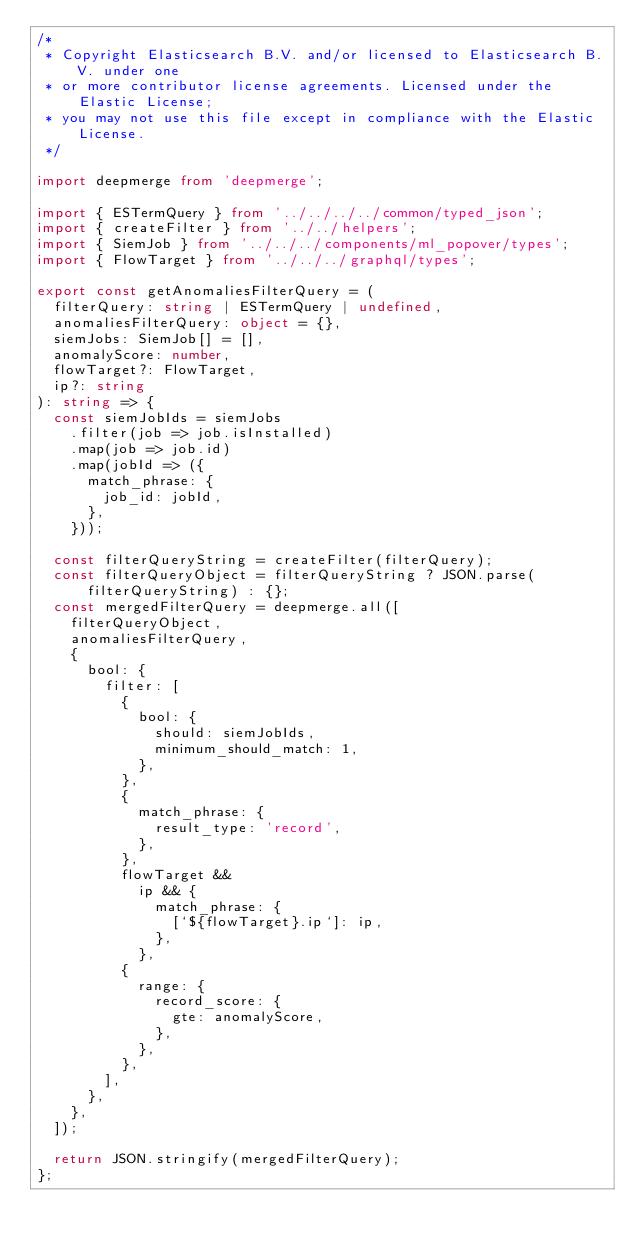Convert code to text. <code><loc_0><loc_0><loc_500><loc_500><_TypeScript_>/*
 * Copyright Elasticsearch B.V. and/or licensed to Elasticsearch B.V. under one
 * or more contributor license agreements. Licensed under the Elastic License;
 * you may not use this file except in compliance with the Elastic License.
 */

import deepmerge from 'deepmerge';

import { ESTermQuery } from '../../../../common/typed_json';
import { createFilter } from '../../helpers';
import { SiemJob } from '../../../components/ml_popover/types';
import { FlowTarget } from '../../../graphql/types';

export const getAnomaliesFilterQuery = (
  filterQuery: string | ESTermQuery | undefined,
  anomaliesFilterQuery: object = {},
  siemJobs: SiemJob[] = [],
  anomalyScore: number,
  flowTarget?: FlowTarget,
  ip?: string
): string => {
  const siemJobIds = siemJobs
    .filter(job => job.isInstalled)
    .map(job => job.id)
    .map(jobId => ({
      match_phrase: {
        job_id: jobId,
      },
    }));

  const filterQueryString = createFilter(filterQuery);
  const filterQueryObject = filterQueryString ? JSON.parse(filterQueryString) : {};
  const mergedFilterQuery = deepmerge.all([
    filterQueryObject,
    anomaliesFilterQuery,
    {
      bool: {
        filter: [
          {
            bool: {
              should: siemJobIds,
              minimum_should_match: 1,
            },
          },
          {
            match_phrase: {
              result_type: 'record',
            },
          },
          flowTarget &&
            ip && {
              match_phrase: {
                [`${flowTarget}.ip`]: ip,
              },
            },
          {
            range: {
              record_score: {
                gte: anomalyScore,
              },
            },
          },
        ],
      },
    },
  ]);

  return JSON.stringify(mergedFilterQuery);
};
</code> 